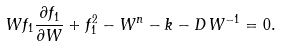Convert formula to latex. <formula><loc_0><loc_0><loc_500><loc_500>W f _ { 1 } \frac { \partial f _ { 1 } } { \partial W } + f _ { 1 } ^ { 2 } - W ^ { n } - k - D \, W ^ { - 1 } = 0 .</formula> 